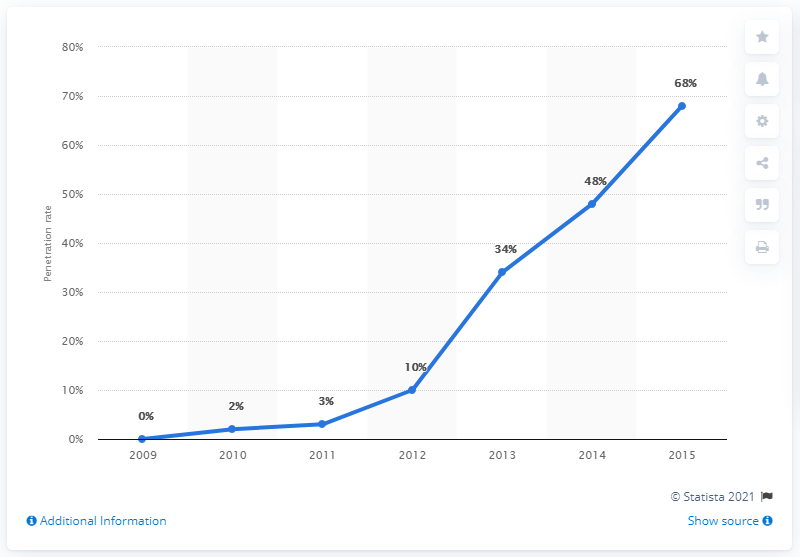Specify some key components in this picture. The line graph begins at zero. The least increase in penetration rate was generated in 2011. In 2015, the penetration rate of rear view cameras was 68%. 